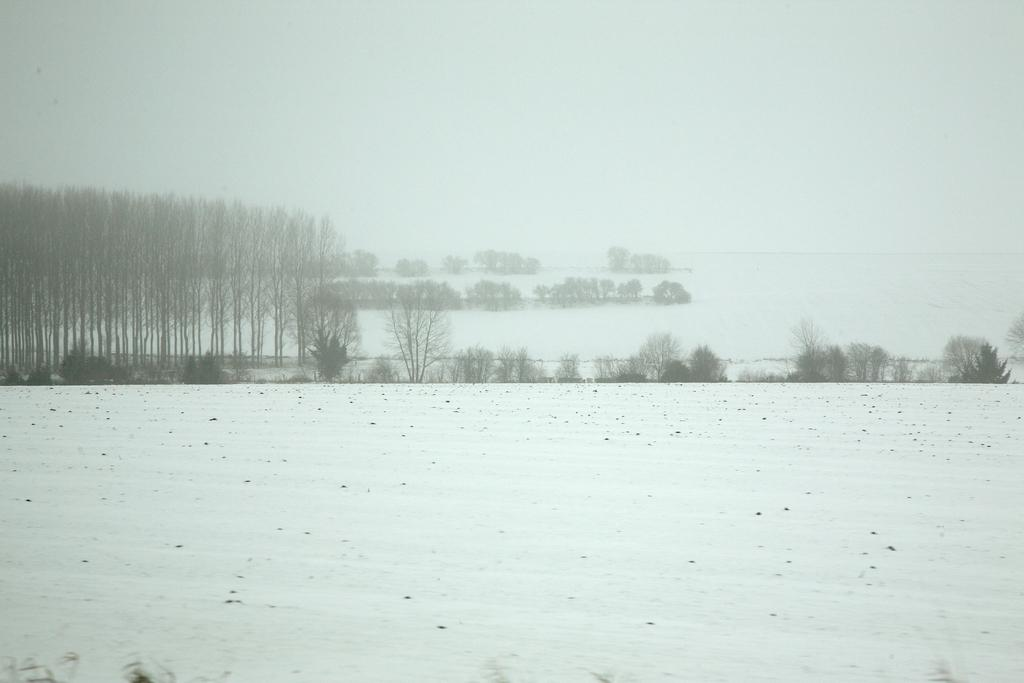What is covering the surface in the image? There is snow on the surface in the image. What can be seen in the distance behind the snowy surface? There are trees and a river in the background of the image. What part of the natural environment is visible in the image? The sky is visible in the background of the image. What type of relation can be seen between the snow and the root in the image? There is no root present in the image, as it only features snow, trees, a river, and the sky. 